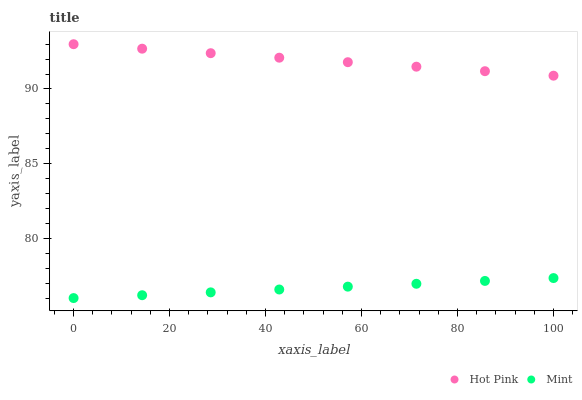Does Mint have the minimum area under the curve?
Answer yes or no. Yes. Does Hot Pink have the maximum area under the curve?
Answer yes or no. Yes. Does Mint have the maximum area under the curve?
Answer yes or no. No. Is Hot Pink the smoothest?
Answer yes or no. Yes. Is Mint the roughest?
Answer yes or no. Yes. Is Mint the smoothest?
Answer yes or no. No. Does Mint have the lowest value?
Answer yes or no. Yes. Does Hot Pink have the highest value?
Answer yes or no. Yes. Does Mint have the highest value?
Answer yes or no. No. Is Mint less than Hot Pink?
Answer yes or no. Yes. Is Hot Pink greater than Mint?
Answer yes or no. Yes. Does Mint intersect Hot Pink?
Answer yes or no. No. 